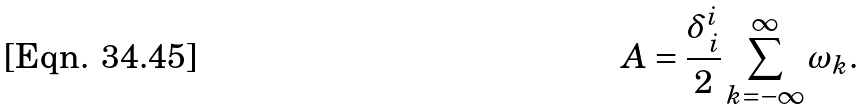Convert formula to latex. <formula><loc_0><loc_0><loc_500><loc_500>A = \frac { \delta ^ { i } _ { \, i } } { 2 } \sum ^ { \infty } _ { k = - \infty } \omega _ { k } .</formula> 